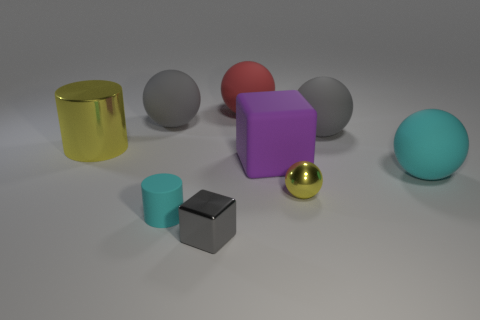Can you tell me how many objects are there and what colors they have? There are eight objects in total. Starting from the left, there's a shiny golden cylinder, a matte gray sphere, a matte pink sphere, a matte lavender cube, a matte turquoise sphere, a small matte cyan cylinder, a reflective chrome cube, and a small glossy golden sphere. 